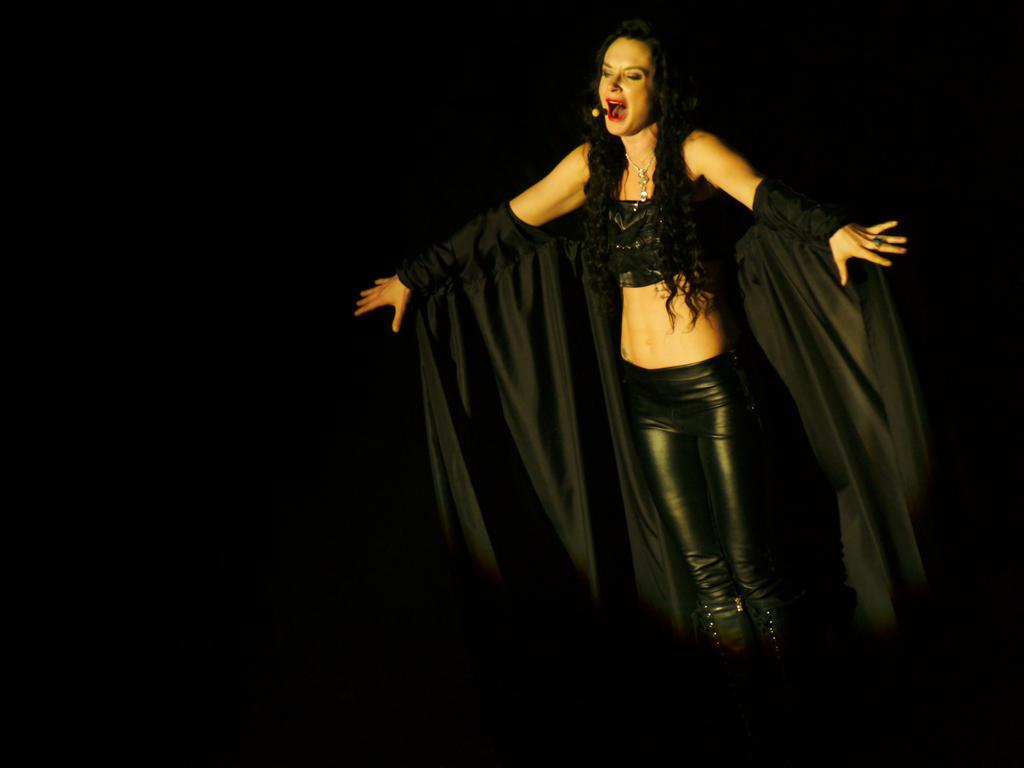Please provide a concise description of this image. In this image I can see a woman is standing on the stage. The background is dark in color. This image is taken may be on the stage. 